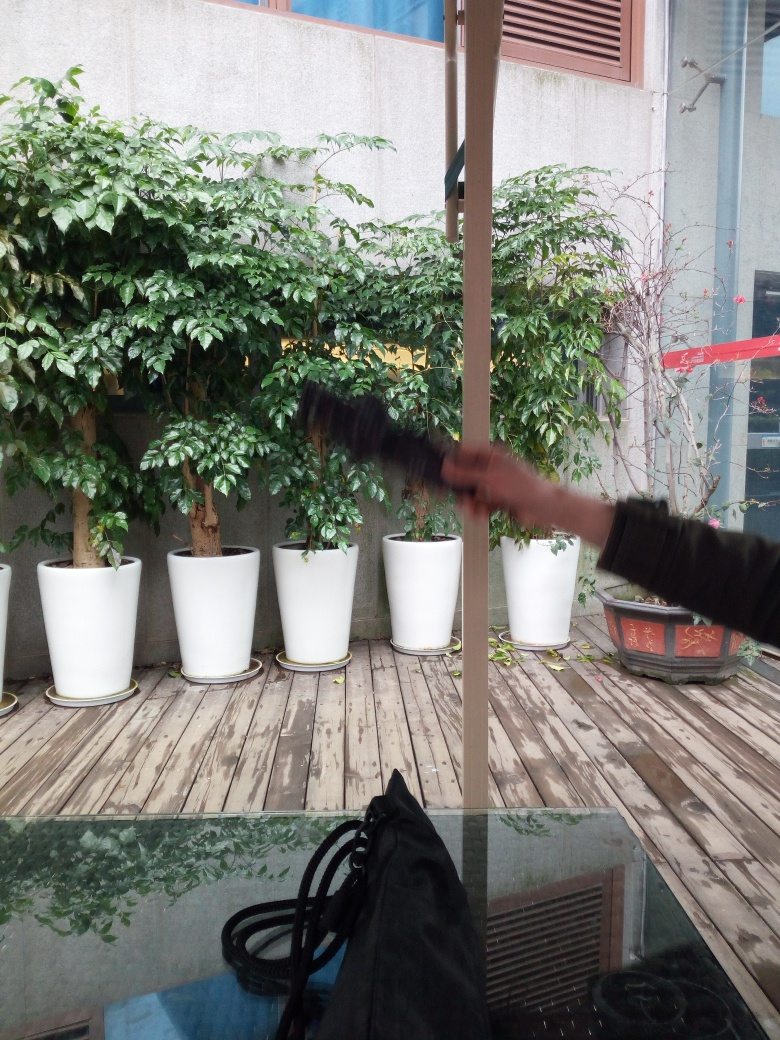Is there some motion blur in the background? Yes, there is noticeable motion blur present, particularly around what appears to be a moving person's arm. This effect often occurs when the camera's exposure time is long enough that moving objects are captured with a trail, indicating movement while the stationary background remains in focus. 